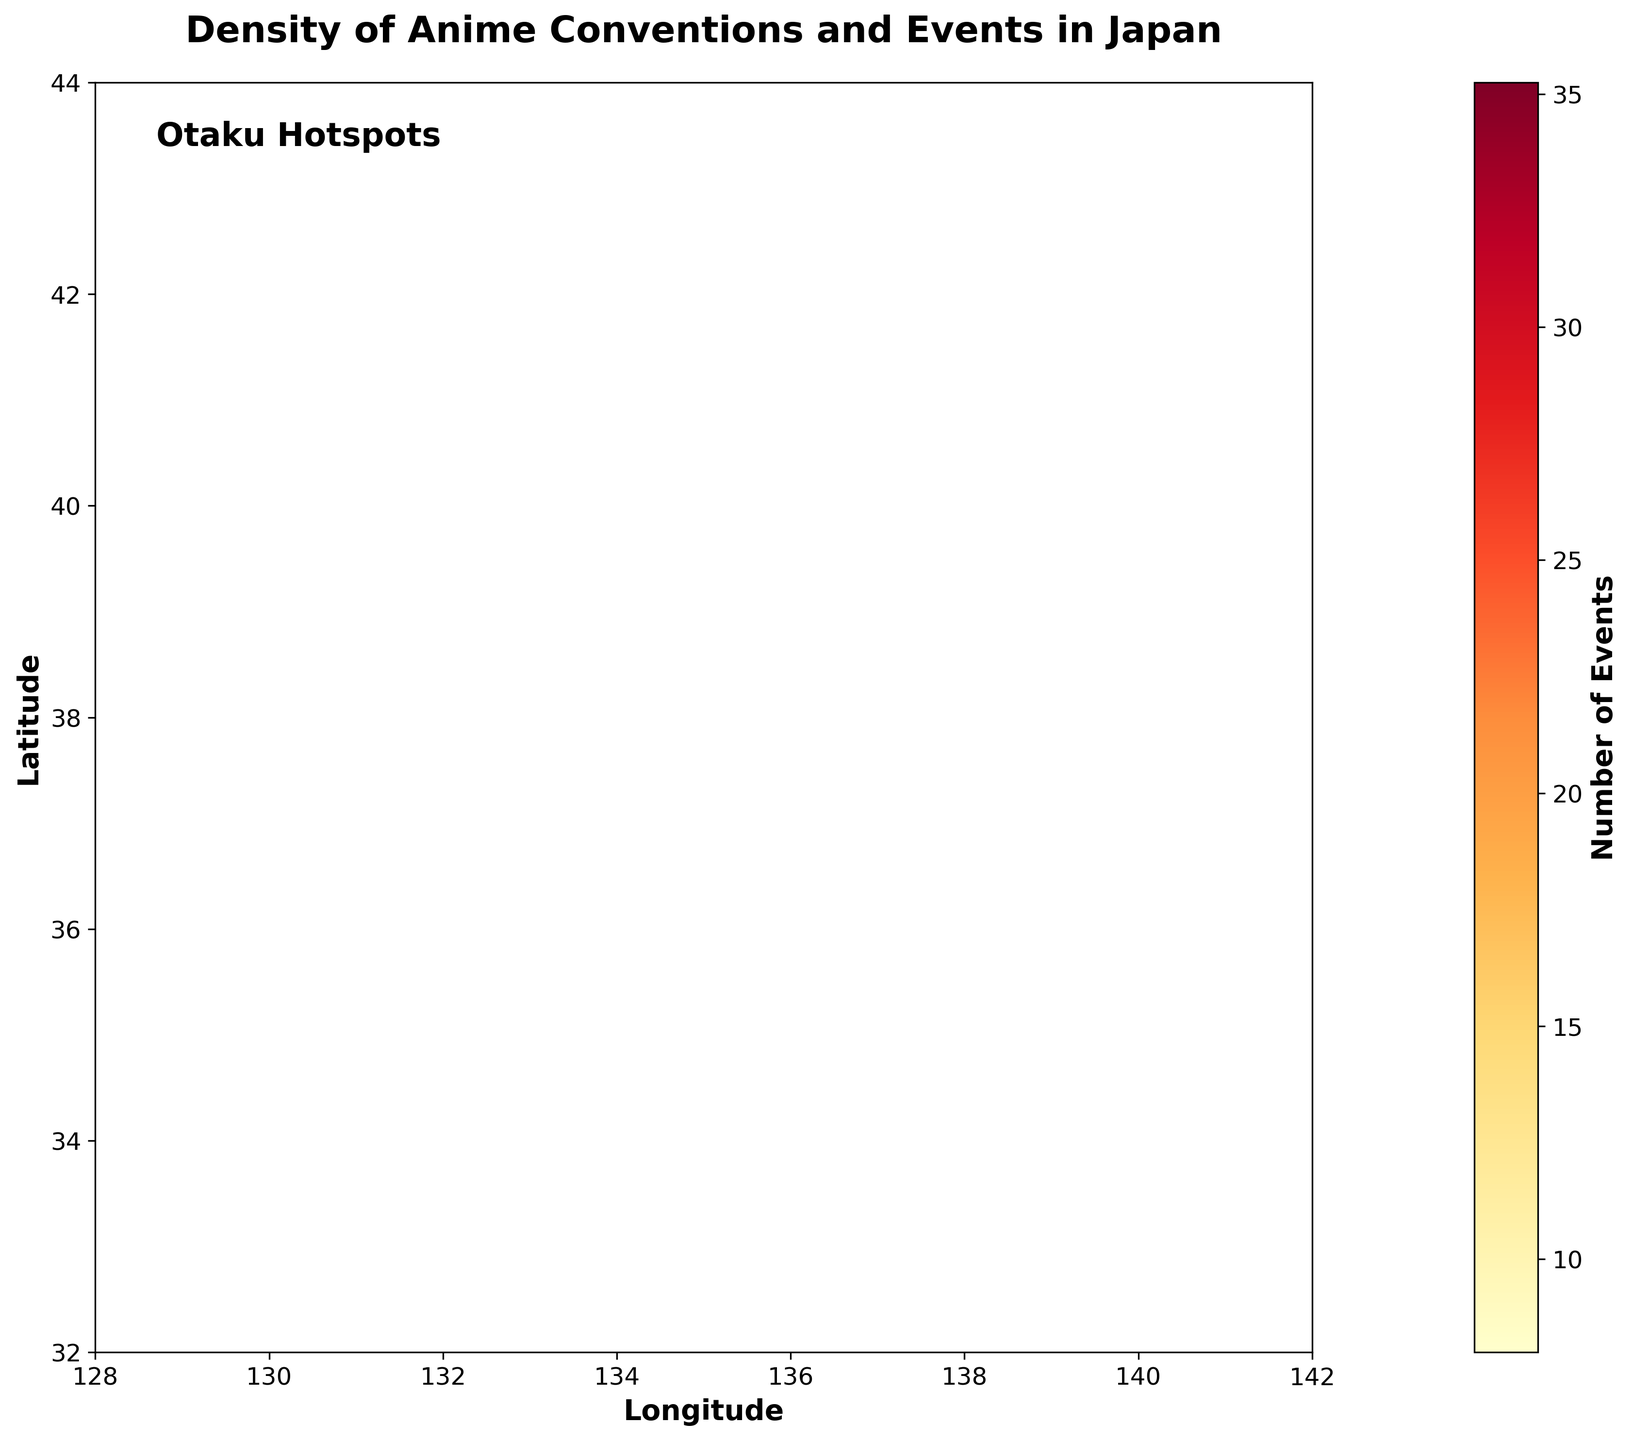What is the title of the figure? The title of the figure is usually clearly displayed at the top, describing the main subject of the plot. The title here is "Density of Anime Conventions and Events in Japan".
Answer: Density of Anime Conventions and Events in Japan What does the color represent in this hexbin plot? In hexbin plots, color typically represents a density or count of occurrences, as indicated by the color bar. In this plot, the colors range from light yellow to dark red, representing an increasing number of events respectively.
Answer: Number of Events What range of longitudes and latitudes does the plot cover? By observing the x-axis and y-axis limits marked on the plot, the longitude range is from 128 to 142 and the latitude range is from 32 to 44.
Answer: Longitude: 128 to 142, Latitude: 32 to 44 Which region has the highest density of anime events? The plot shows hexagons filled with varying colors. The region with the darkest red color, indicating the highest density of events, seems to be around Tokyo (coordinates close to 35.6895, 139.6917).
Answer: Tokyo What does the textbox on the plot say? There is a textbox on the plot indicating a notable annotation. This text is clearly readable and says "Otaku Hotspots".
Answer: Otaku Hotspots Which regions have more than 30 events? By checking the hexagons with dark red and the values on the color bar, we can see that regions around Tokyo (35.6895, 139.6917; 35.6586, 139.7454; etc.) and other nearby coordinates have counts above 30.
Answer: Tokyo and nearby regions What is the color at the coordinates (35.0116, 135.7681)? By locating the coordinates and observing the color, we can see that it corresponds to an orange shade linked to about 28 events, as indicated by the color bar.
Answer: Orange How many regions have between 20 and 30 events? By counting the hexagons with colors corresponding to that range on the color bar (between light orange and dark orange), we can identify approximately 5 regions.
Answer: 5 Which coordinate has a lower density of events: (35.6586, 139.7454) or (35.7442, 139.3539)? By comparing the color intensity at these two coordinates, (35.7442, 139.3539) has a lighter shade than (35.6586, 139.7454), indicating fewer events.
Answer: (35.7442, 139.3539) What is the purpose of the color bar in this hexbin plot? The color bar helps interpret the density or count represented by different colors on the plot. The numeric values and gradient colors assist in correlating hexagon shades with the number of events.
Answer: To interpret event density 